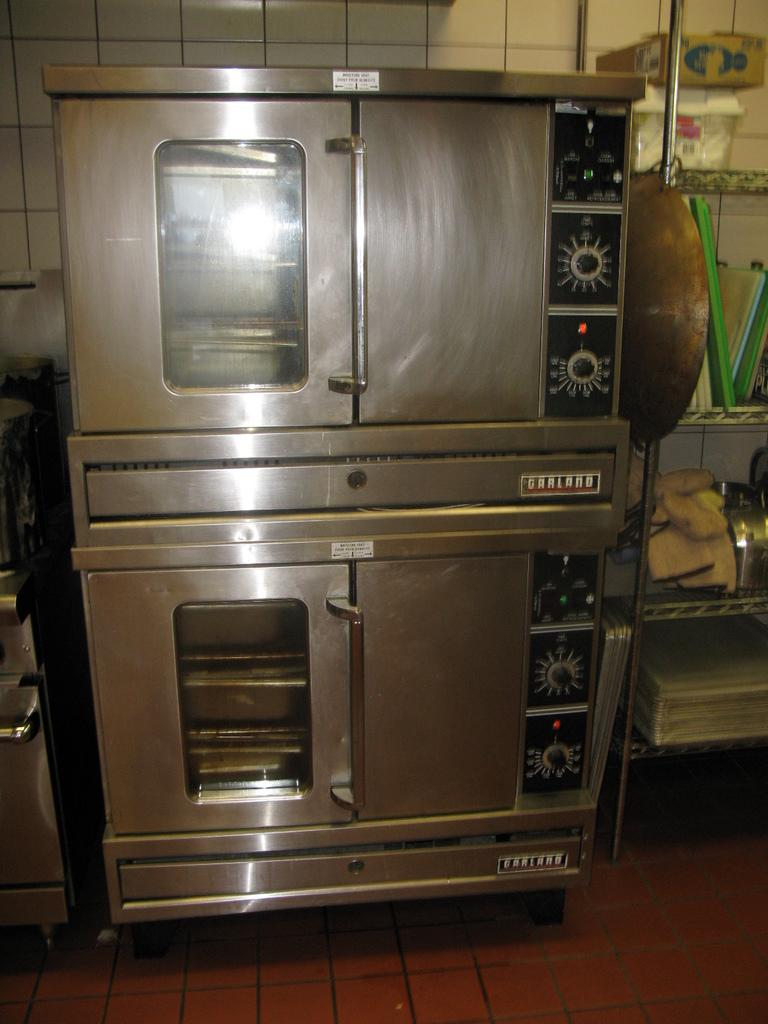What is the main object in the front of the image? There is a machine in the front of the image. What can be seen on the right side of the image? There is a stand on the right side of the image. What is placed on the stand? There are objects on the stand. What colors are visible on the objects? The objects have white, brown, and green colors. What type of cake is being prepared on the machine in the image? There is no cake or cake preparation visible in the image; it features a machine and a stand with objects of various colors. What territory is being claimed by the objects on the stand? The objects on the stand are not claiming any territory; they are simply placed on the stand. 